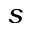<formula> <loc_0><loc_0><loc_500><loc_500>s</formula> 